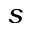<formula> <loc_0><loc_0><loc_500><loc_500>s</formula> 